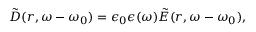Convert formula to latex. <formula><loc_0><loc_0><loc_500><loc_500>\tilde { D } ( r , \omega - \omega _ { 0 } ) = \epsilon _ { 0 } \epsilon ( \omega ) \tilde { E } ( r , \omega - \omega _ { 0 } ) ,</formula> 